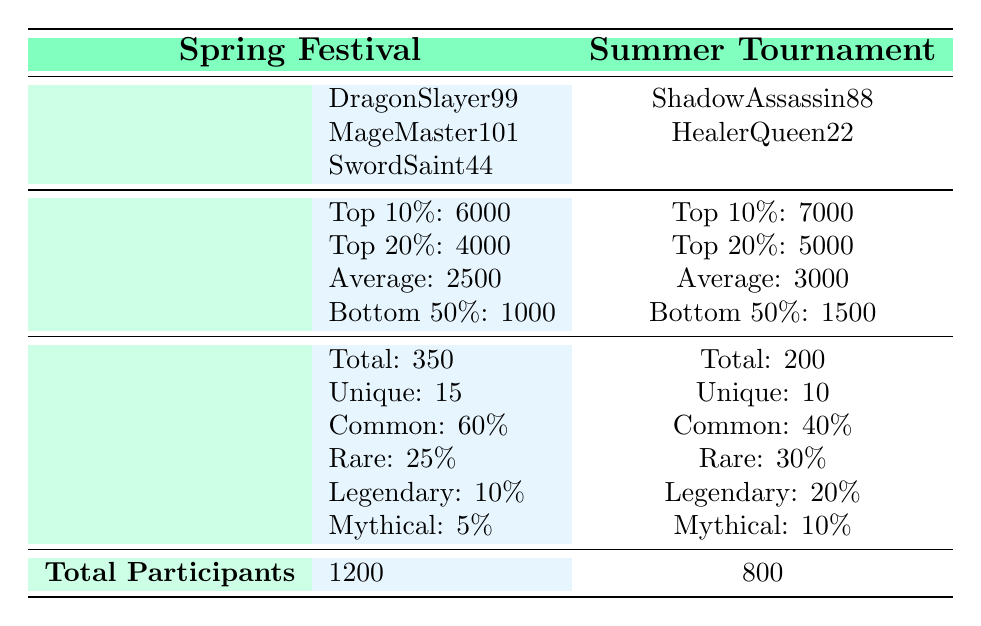What is the total number of players in the Spring Festival? The table states that the total number of participants in the Spring Festival is specifically noted as 1200.
Answer: 1200 How much gold did the top player in the Summer Tournament receive? The table highlights that the top player in the Summer Tournament, ShadowAssassin88, received 8000 gold.
Answer: 8000 What are the unique items awarded in the Spring Festival? The Spring Festival awarded a total of 15 unique items, as indicated in the table under the Rare Items section for the Spring Festival.
Answer: 15 Which seasonal event had a higher average gold distribution? For the Spring Festival, the average gold distribution is noted as 2500, while in the Summer Tournament, it is 3000. Since 3000 is greater than 2500, the Summer Tournament had a higher average.
Answer: Summer Tournament How much total rare items were awarded in the Summer Tournament compared to the Spring Festival? The table states that the total rare items awarded in the Summer Tournament were 200, whereas in the Spring Festival, a total of 350 rare items were awarded. The Spring Festival had 150 more rare items awarded than the Summer Tournament.
Answer: Spring Festival Is it true that the Bottom 50% of players in the Summer Tournament received more than 1000 gold? The Bottom 50% gold distribution in the Summer Tournament is noted as 1500 gold, which is indeed greater than 1000. Thus, the statement is true.
Answer: Yes What percentage of rare items awarded in the Spring Festival were categorized as Legendary? According to the table, the Legendary items in the Spring Festival account for 10 out of a total of 350 items. To find the percentage: (10/350)*100 = approximately 2.86%.
Answer: 2.86% Which top player in the Spring Festival received the least gold? Among the top players in the Spring Festival, SwordSaint44 is listed with rewards of 3000 gold, which is less than both DragonSlayer99 (5000 gold) and MageMaster101 (3500 gold). Therefore, SwordSaint44 received the least gold.
Answer: SwordSaint44 How much more gold did the top 10% earn in the Summer Tournament compared to the Spring Festival? The top 10% in the Summer Tournament earned 7000 gold, whereas the top 10% in the Spring Festival earned 6000 gold. The difference is 7000 - 6000 = 1000 gold more for the Summer Tournament's top 10%.
Answer: 1000 